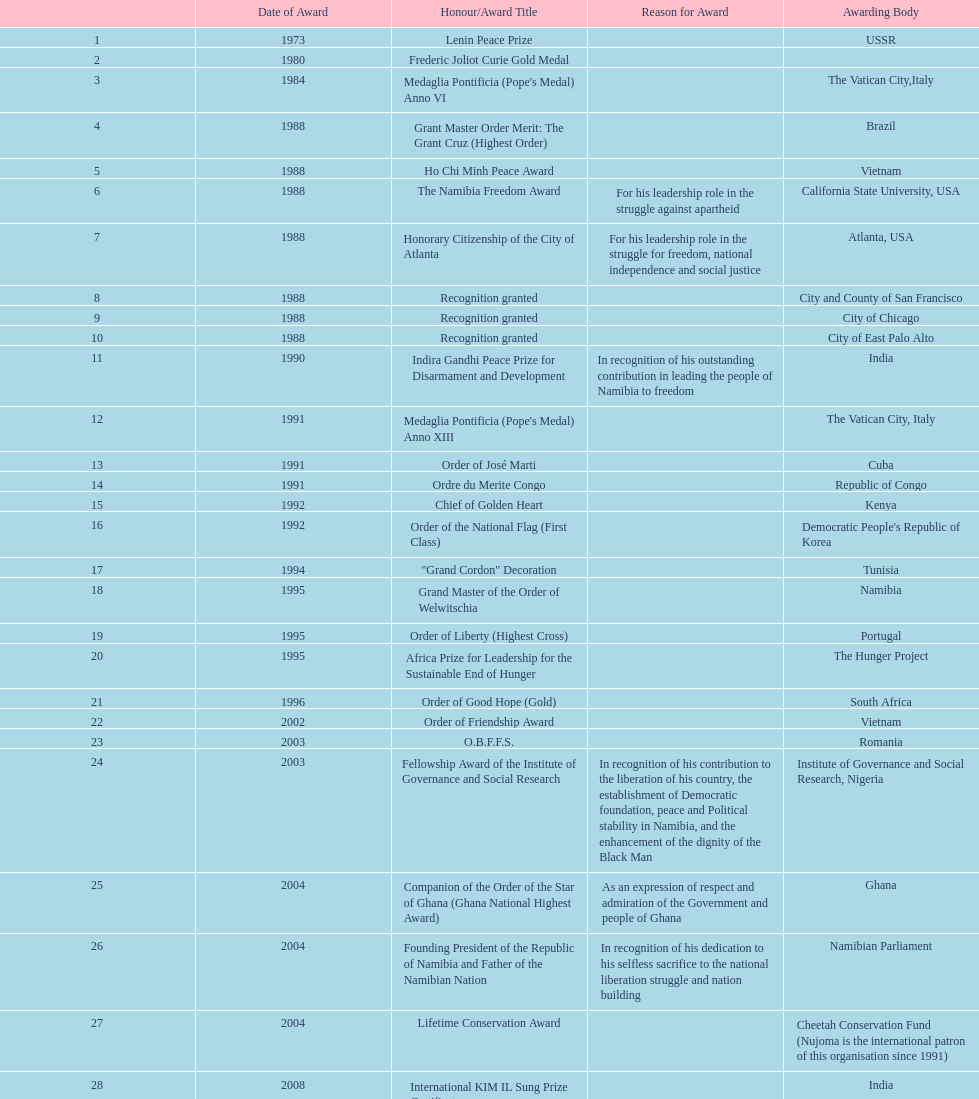I'm looking to parse the entire table for insights. Could you assist me with that? {'header': ['', 'Date of Award', 'Honour/Award Title', 'Reason for Award', 'Awarding Body'], 'rows': [['1', '1973', 'Lenin Peace Prize', '', 'USSR'], ['2', '1980', 'Frederic Joliot Curie Gold Medal', '', ''], ['3', '1984', "Medaglia Pontificia (Pope's Medal) Anno VI", '', 'The Vatican City,Italy'], ['4', '1988', 'Grant Master Order Merit: The Grant Cruz (Highest Order)', '', 'Brazil'], ['5', '1988', 'Ho Chi Minh Peace Award', '', 'Vietnam'], ['6', '1988', 'The Namibia Freedom Award', 'For his leadership role in the struggle against apartheid', 'California State University, USA'], ['7', '1988', 'Honorary Citizenship of the City of Atlanta', 'For his leadership role in the struggle for freedom, national independence and social justice', 'Atlanta, USA'], ['8', '1988', 'Recognition granted', '', 'City and County of San Francisco'], ['9', '1988', 'Recognition granted', '', 'City of Chicago'], ['10', '1988', 'Recognition granted', '', 'City of East Palo Alto'], ['11', '1990', 'Indira Gandhi Peace Prize for Disarmament and Development', 'In recognition of his outstanding contribution in leading the people of Namibia to freedom', 'India'], ['12', '1991', "Medaglia Pontificia (Pope's Medal) Anno XIII", '', 'The Vatican City, Italy'], ['13', '1991', 'Order of José Marti', '', 'Cuba'], ['14', '1991', 'Ordre du Merite Congo', '', 'Republic of Congo'], ['15', '1992', 'Chief of Golden Heart', '', 'Kenya'], ['16', '1992', 'Order of the National Flag (First Class)', '', "Democratic People's Republic of Korea"], ['17', '1994', '"Grand Cordon" Decoration', '', 'Tunisia'], ['18', '1995', 'Grand Master of the Order of Welwitschia', '', 'Namibia'], ['19', '1995', 'Order of Liberty (Highest Cross)', '', 'Portugal'], ['20', '1995', 'Africa Prize for Leadership for the Sustainable End of Hunger', '', 'The Hunger Project'], ['21', '1996', 'Order of Good Hope (Gold)', '', 'South Africa'], ['22', '2002', 'Order of Friendship Award', '', 'Vietnam'], ['23', '2003', 'O.B.F.F.S.', '', 'Romania'], ['24', '2003', 'Fellowship Award of the Institute of Governance and Social Research', 'In recognition of his contribution to the liberation of his country, the establishment of Democratic foundation, peace and Political stability in Namibia, and the enhancement of the dignity of the Black Man', 'Institute of Governance and Social Research, Nigeria'], ['25', '2004', 'Companion of the Order of the Star of Ghana (Ghana National Highest Award)', 'As an expression of respect and admiration of the Government and people of Ghana', 'Ghana'], ['26', '2004', 'Founding President of the Republic of Namibia and Father of the Namibian Nation', 'In recognition of his dedication to his selfless sacrifice to the national liberation struggle and nation building', 'Namibian Parliament'], ['27', '2004', 'Lifetime Conservation Award', '', 'Cheetah Conservation Fund (Nujoma is the international patron of this organisation since 1991)'], ['28', '2008', 'International KIM IL Sung Prize Certificate', '', 'India'], ['29', '2010', 'Sir Seretse Khama SADC Meda', '', 'SADC']]} What is the total number of awards that nujoma won? 29. 